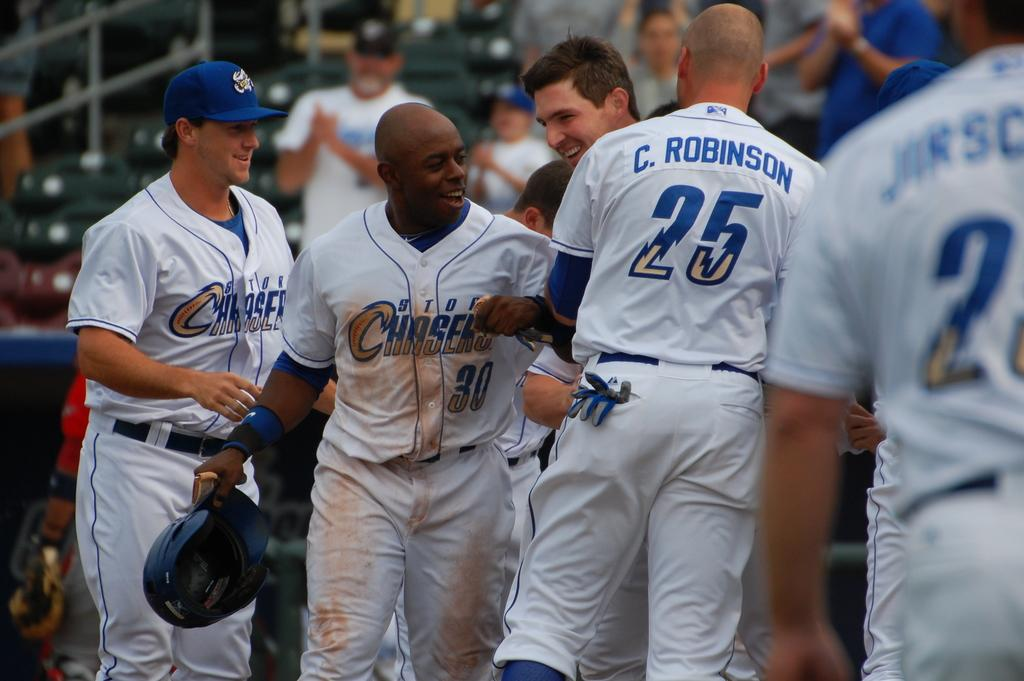<image>
Summarize the visual content of the image. players for the storm chasers happy and laughing 